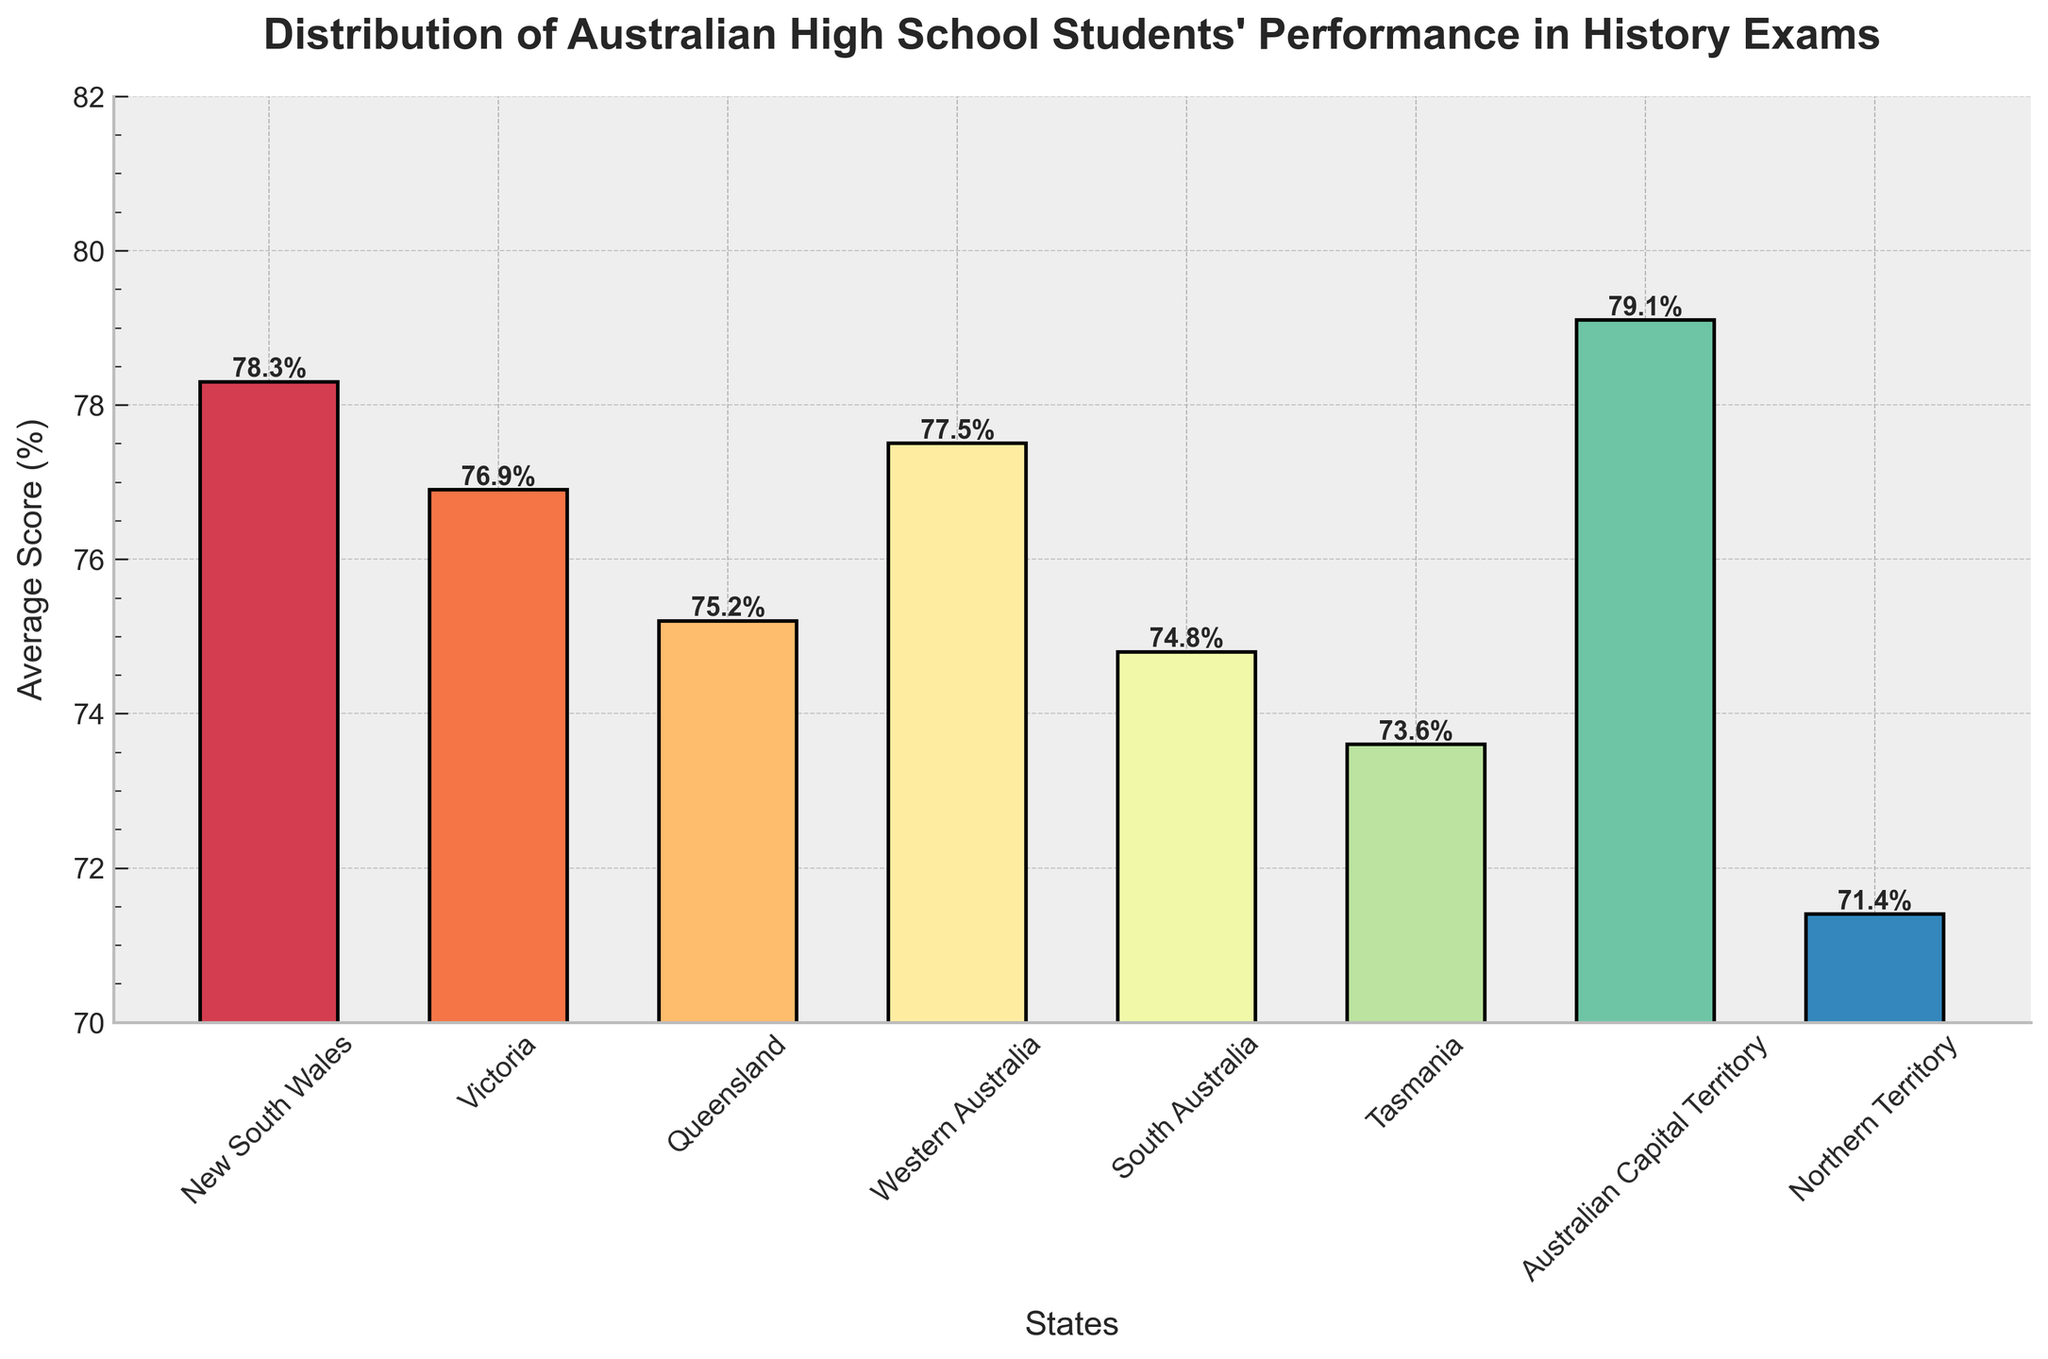What's the highest average score recorded among the states? The highest bar represents the highest average score. From the height of the bars, the Australian Capital Territory has the highest average with a score of 79.1%.
Answer: 79.1% Which state has the lowest average score? The shortest bar represents the lowest average score. The bar for the Northern Territory is the shortest with an average score of 71.4%.
Answer: 71.4% How much higher is the average score in New South Wales compared to Tasmania? Find the height difference between New South Wales and Tasmania bars. New South Wales has 78.3% and Tasmania has 73.6%. The difference is 78.3 - 73.6 = 4.7%.
Answer: 4.7% Which states have average scores greater than 77%? Identify the bars with heights above 77%. New South Wales, Western Australia, and Australian Capital Territory have scores above 77%.
Answer: New South Wales, Western Australia, Australian Capital Territory Compare the average scores of Victoria and South Australia – which is higher and by how much? Look at the bars' heights for Victoria and South Australia. Victoria has a higher score with 76.9% compared to South Australia's 74.8%. The difference is 76.9 - 74.8 = 2.1%.
Answer: Victoria by 2.1% What is the mean average score of all the states? Sum all the average scores and divide by the number of states. The scores are: 78.3, 76.9, 75.2, 77.5, 74.8, 73.6, 79.1, 71.4. Sum = 606.8. Number of states = 8. Mean = 606.8 / 8 = 75.85%.
Answer: 75.85% Which state has an average score most similar to Queensland? Look for the state with a score closest to Queensland, which is 75.2%. South Australia has a score of 74.8%, which is closest to 75.2%.
Answer: South Australia By how much does the average score of Western Australia exceed the average score of Northern Territory? Calculate the difference in the heights of the Western Australia and Northern Territory bars. Western Australia has 77.5%, and Northern Territory has 71.4%. The difference is 77.5 - 71.4 = 6.1%.
Answer: 6.1% What is the range of the average scores across the states? The range is the difference between the highest and lowest scores. The highest is Australian Capital Territory with 79.1%, and the lowest is Northern Territory with 71.4%. Range = 79.1 - 71.4 = 7.7%.
Answer: 7.7% What's the average score difference between the highest and the lowest performing states? Identify the highest performing state (Australian Capital Territory with 79.1%) and the lowest performing state (Northern Territory with 71.4%). The difference is 79.1 - 71.4 = 7.7%.
Answer: 7.7% 